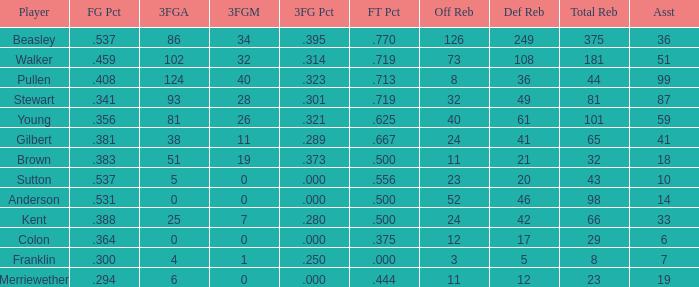What is the total number of offensive rebounds for players with more than 124 3-point attempts? 0.0. 